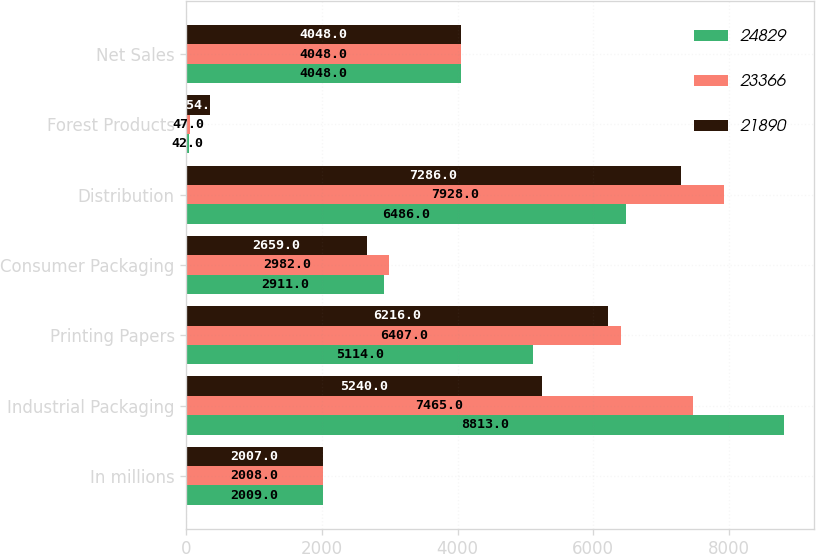Convert chart. <chart><loc_0><loc_0><loc_500><loc_500><stacked_bar_chart><ecel><fcel>In millions<fcel>Industrial Packaging<fcel>Printing Papers<fcel>Consumer Packaging<fcel>Distribution<fcel>Forest Products<fcel>Net Sales<nl><fcel>24829<fcel>2009<fcel>8813<fcel>5114<fcel>2911<fcel>6486<fcel>42<fcel>4048<nl><fcel>23366<fcel>2008<fcel>7465<fcel>6407<fcel>2982<fcel>7928<fcel>47<fcel>4048<nl><fcel>21890<fcel>2007<fcel>5240<fcel>6216<fcel>2659<fcel>7286<fcel>354<fcel>4048<nl></chart> 